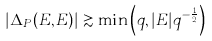Convert formula to latex. <formula><loc_0><loc_0><loc_500><loc_500>| \Delta _ { P } ( E , E ) | \gtrsim \min \left ( q , | E | q ^ { - \frac { 1 } { 2 } } \right )</formula> 